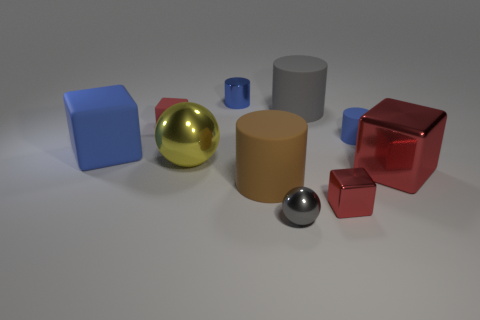The big yellow thing is what shape?
Provide a short and direct response. Sphere. How many cylinders have the same material as the blue cube?
Ensure brevity in your answer.  3. What color is the large block that is the same material as the tiny gray ball?
Offer a terse response. Red. Do the rubber thing behind the red matte cube and the small shiny cylinder have the same size?
Keep it short and to the point. No. There is a big matte thing that is the same shape as the tiny red metal object; what is its color?
Make the answer very short. Blue. What shape is the rubber thing that is right of the tiny red thing in front of the tiny matte object on the left side of the big yellow shiny object?
Your answer should be compact. Cylinder. Does the large yellow metallic object have the same shape as the large red thing?
Make the answer very short. No. What is the shape of the gray object behind the blue cylinder in front of the large gray rubber object?
Offer a terse response. Cylinder. Are there any big red metal things?
Your answer should be very brief. Yes. How many tiny red shiny cubes are left of the large red shiny block in front of the blue thing in front of the blue matte cylinder?
Provide a succinct answer. 1. 